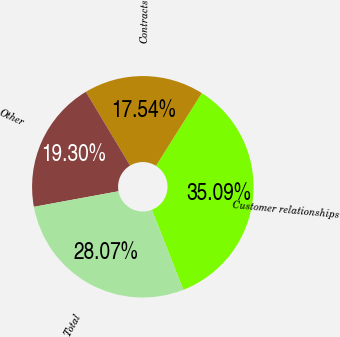Convert chart to OTSL. <chart><loc_0><loc_0><loc_500><loc_500><pie_chart><fcel>Customer relationships<fcel>Contracts<fcel>Other<fcel>Total<nl><fcel>35.09%<fcel>17.54%<fcel>19.3%<fcel>28.07%<nl></chart> 